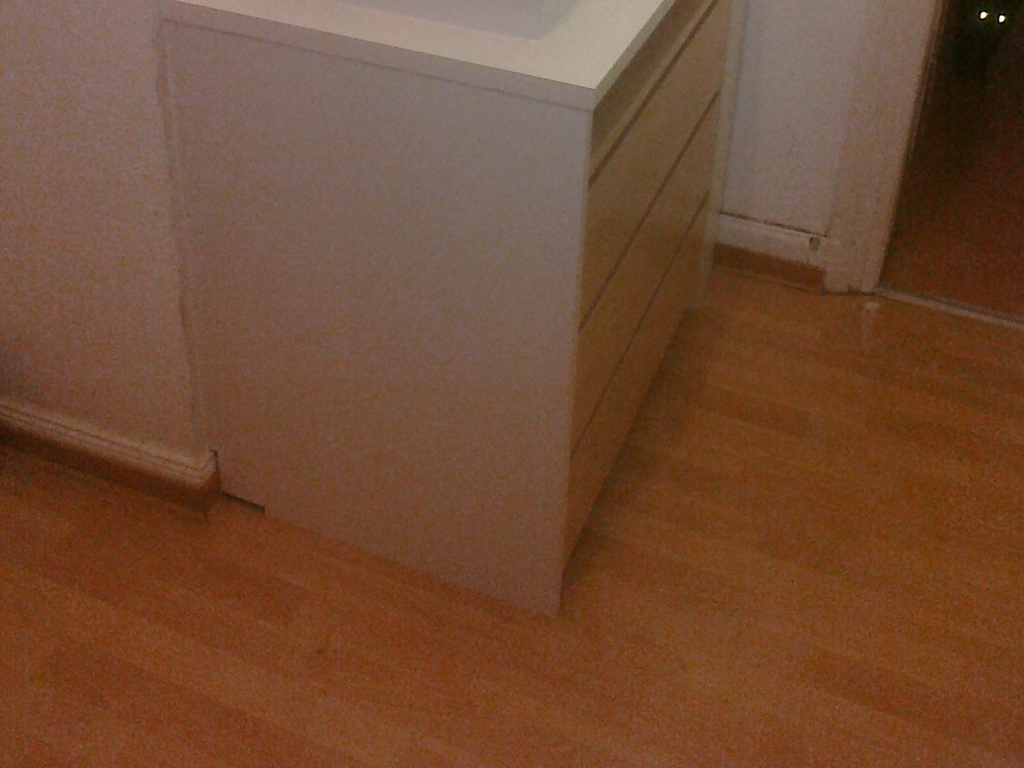What kind of room might this image depict, and what is the possible function of the cabinet in there? This image is likely to depict a part of a kitchen or a living room space, given the appearance of the cabinet. Its function could vary; in a kitchen, it might store utensils, cookware, or pantry items, whereas in a living room, it might be used to keep books, decor, or multimedia equipment organized. 